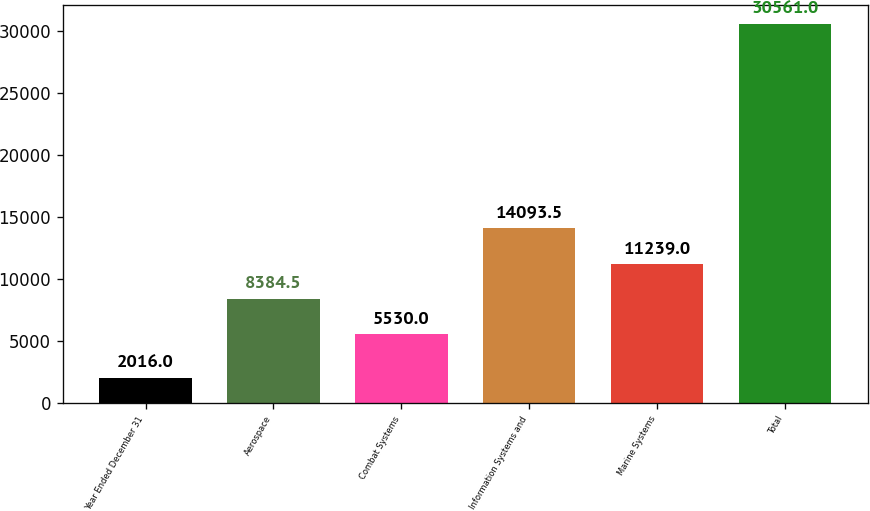<chart> <loc_0><loc_0><loc_500><loc_500><bar_chart><fcel>Year Ended December 31<fcel>Aerospace<fcel>Combat Systems<fcel>Information Systems and<fcel>Marine Systems<fcel>Total<nl><fcel>2016<fcel>8384.5<fcel>5530<fcel>14093.5<fcel>11239<fcel>30561<nl></chart> 